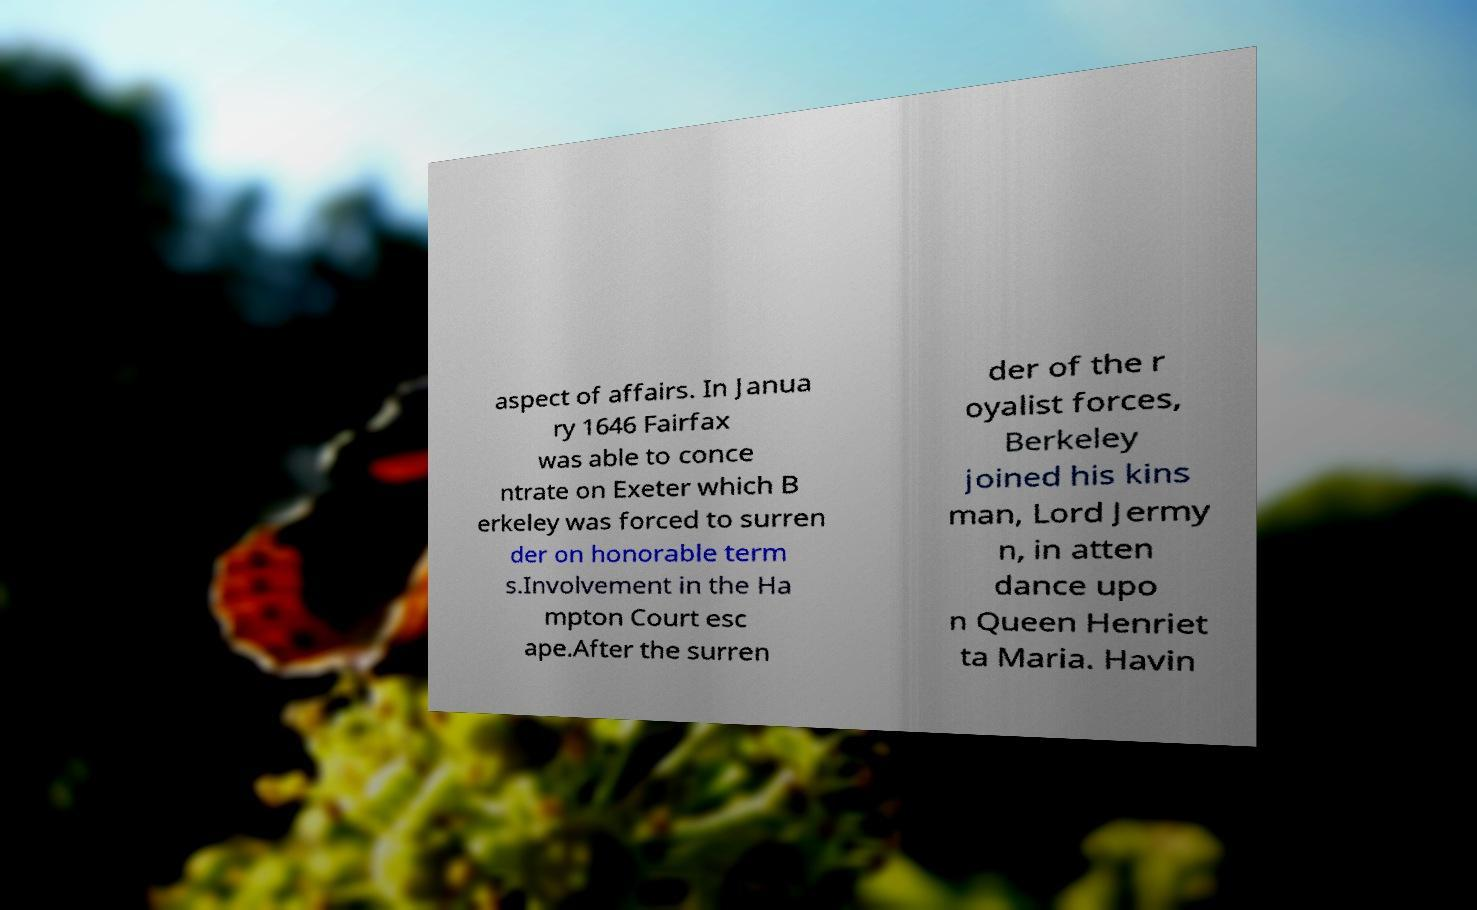Could you extract and type out the text from this image? aspect of affairs. In Janua ry 1646 Fairfax was able to conce ntrate on Exeter which B erkeley was forced to surren der on honorable term s.Involvement in the Ha mpton Court esc ape.After the surren der of the r oyalist forces, Berkeley joined his kins man, Lord Jermy n, in atten dance upo n Queen Henriet ta Maria. Havin 